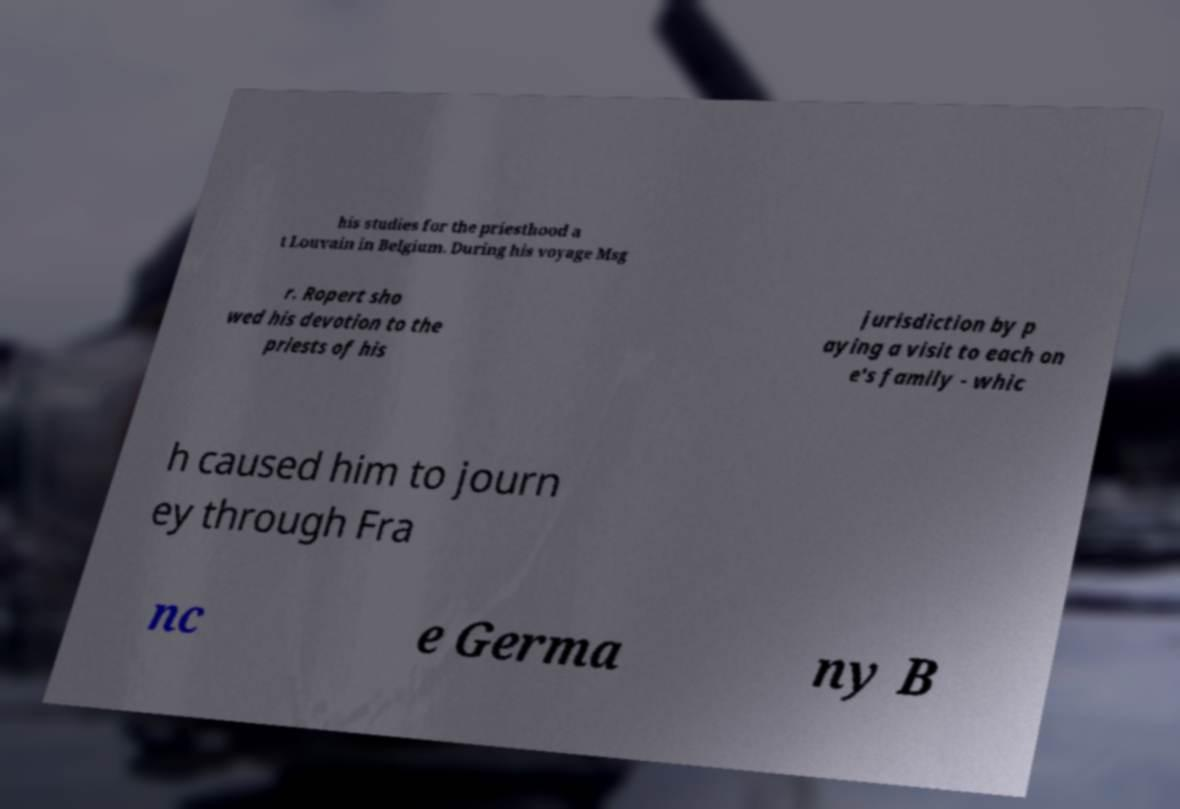I need the written content from this picture converted into text. Can you do that? his studies for the priesthood a t Louvain in Belgium. During his voyage Msg r. Ropert sho wed his devotion to the priests of his jurisdiction by p aying a visit to each on e's family - whic h caused him to journ ey through Fra nc e Germa ny B 